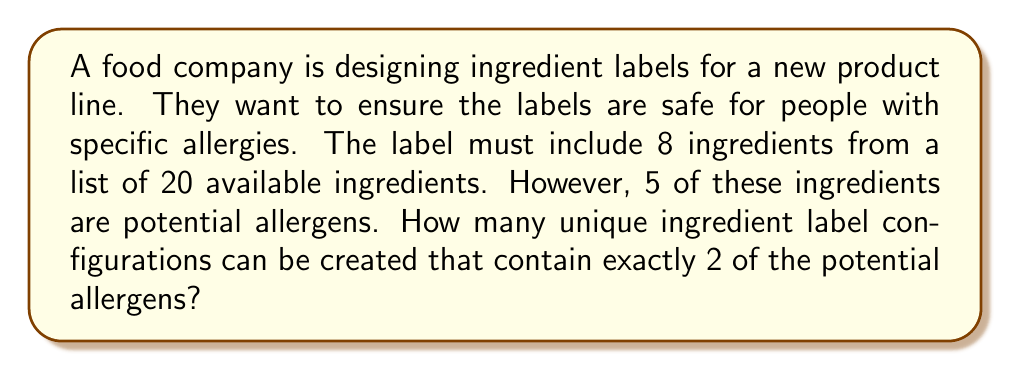What is the answer to this math problem? Let's approach this step-by-step:

1) First, we need to choose 2 allergens from the 5 potential allergens:
   $${5 \choose 2} = \frac{5!}{2!(5-2)!} = 10$$

2) Next, we need to choose 6 non-allergen ingredients from the remaining 15 ingredients:
   $${15 \choose 6} = \frac{15!}{6!(15-6)!} = 5005$$

3) The total number of ways to arrange these 8 ingredients (2 allergens + 6 non-allergens) is:
   $$8! = 40320$$

4) By the Multiplication Principle, the total number of unique ingredient label configurations is:
   $$10 \times 5005 \times 40320 = 2,018,016,000$$

This large number emphasizes the importance of carefully checking ingredient labels for those with allergies, as there are many possible combinations.
Answer: 2,018,016,000 